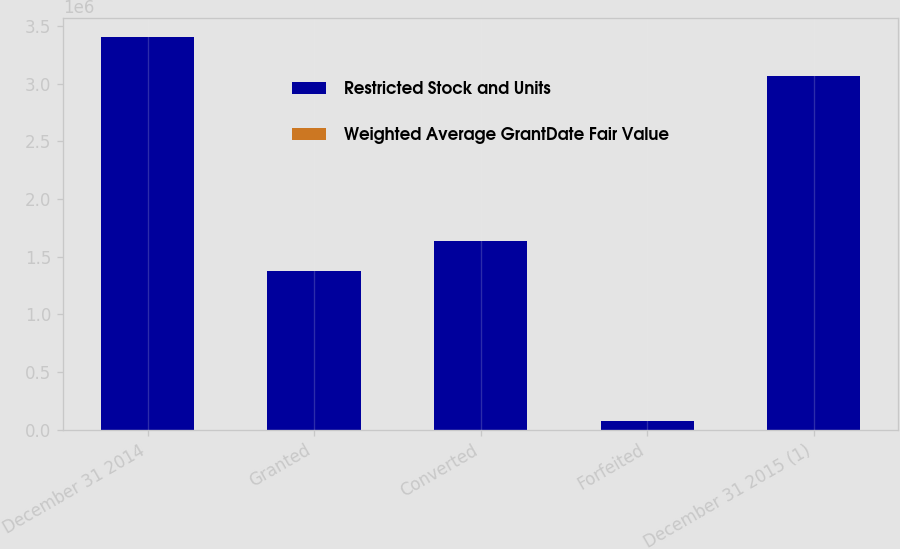Convert chart. <chart><loc_0><loc_0><loc_500><loc_500><stacked_bar_chart><ecel><fcel>December 31 2014<fcel>Granted<fcel>Converted<fcel>Forfeited<fcel>December 31 2015 (1)<nl><fcel>Restricted Stock and Units<fcel>3.40191e+06<fcel>1.37726e+06<fcel>1.63908e+06<fcel>72357<fcel>3.06774e+06<nl><fcel>Weighted Average GrantDate Fair Value<fcel>257.01<fcel>343.49<fcel>231.26<fcel>306.41<fcel>308.42<nl></chart> 